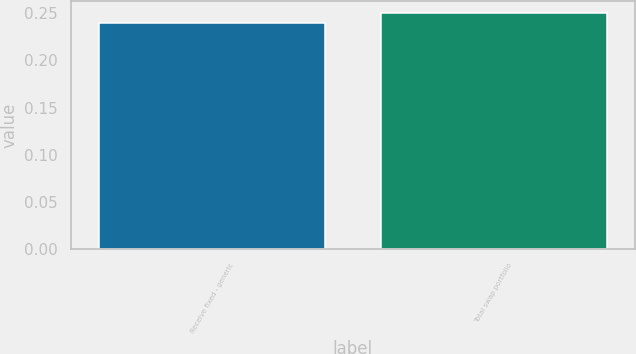<chart> <loc_0><loc_0><loc_500><loc_500><bar_chart><fcel>Receive fixed - generic<fcel>Total swap portfolio<nl><fcel>0.24<fcel>0.25<nl></chart> 